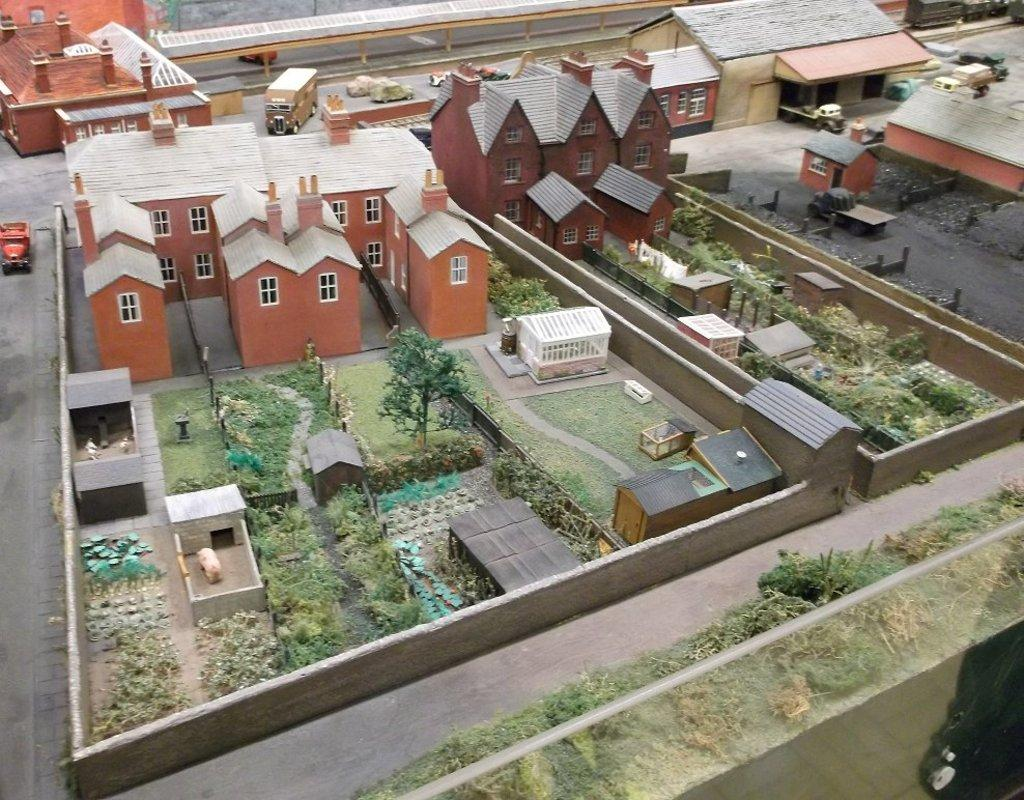What is the main subject of the image? The main subject of the image is a model of houses. What is located in front of the houses? There is a garden in front of the houses. What else can be seen in the image? There is a road in the image. What is happening on the road? Vehicles are present on the road. Where can the snail be found in the image? There is no snail present in the image. What type of cakes are being served in the lunchroom in the image? There is no lunchroom or cakes present in the image. 